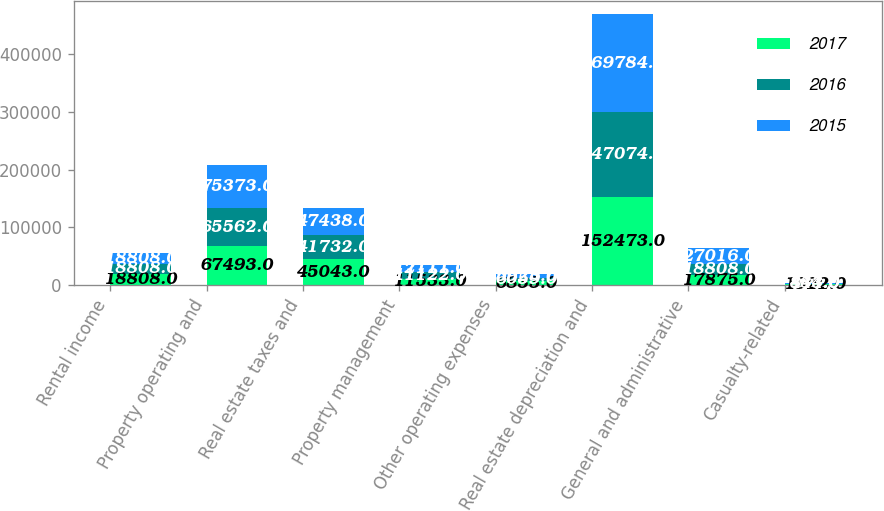Convert chart to OTSL. <chart><loc_0><loc_0><loc_500><loc_500><stacked_bar_chart><ecel><fcel>Rental income<fcel>Property operating and<fcel>Real estate taxes and<fcel>Property management<fcel>Other operating expenses<fcel>Real estate depreciation and<fcel>General and administrative<fcel>Casualty-related<nl><fcel>2017<fcel>18808<fcel>67493<fcel>45043<fcel>11533<fcel>6833<fcel>152473<fcel>17875<fcel>1922<nl><fcel>2016<fcel>18808<fcel>65562<fcel>41732<fcel>11122<fcel>6059<fcel>147074<fcel>18808<fcel>484<nl><fcel>2015<fcel>18808<fcel>75373<fcel>47438<fcel>12111<fcel>5923<fcel>169784<fcel>27016<fcel>843<nl></chart> 